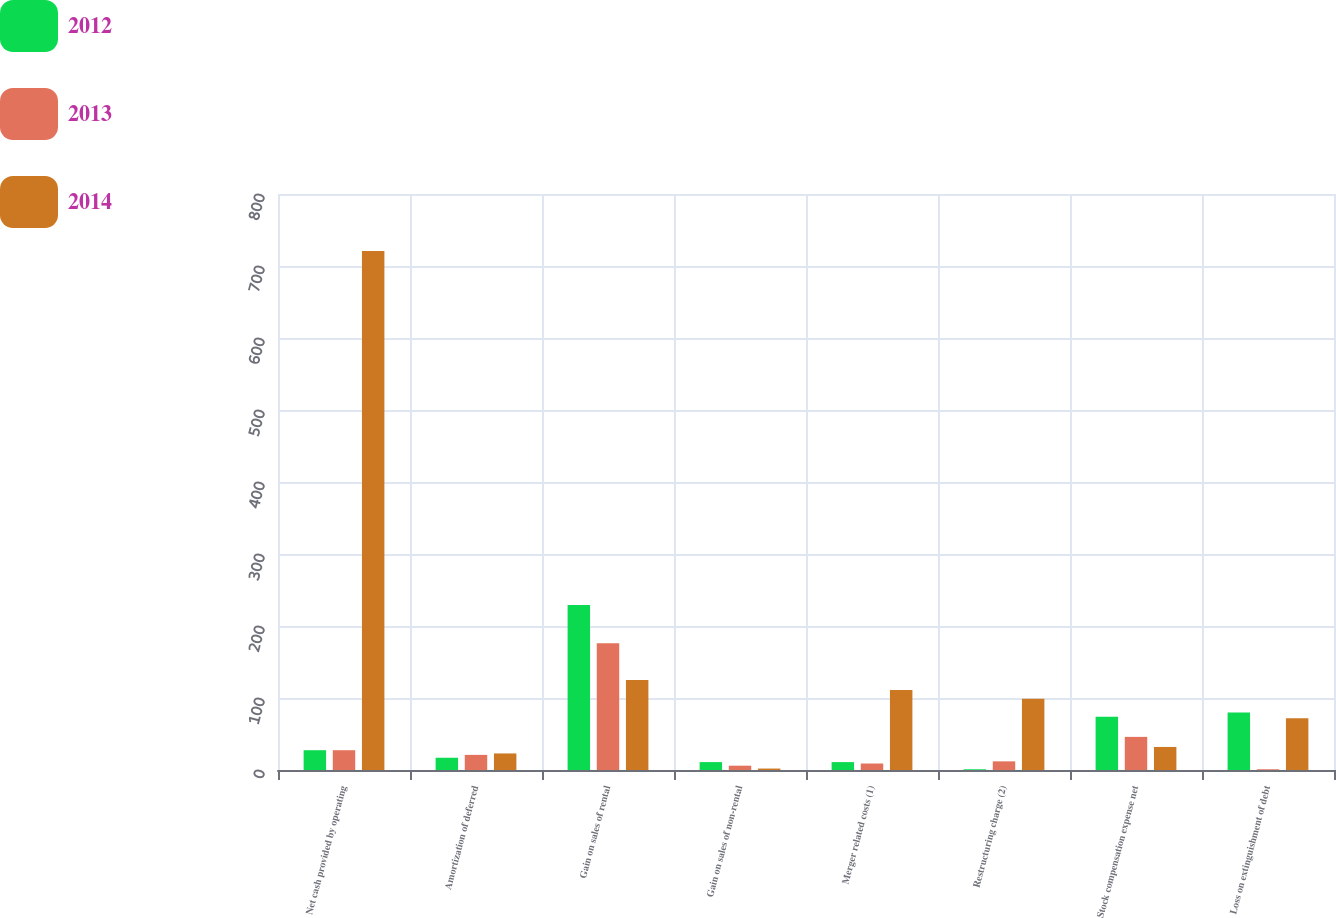Convert chart. <chart><loc_0><loc_0><loc_500><loc_500><stacked_bar_chart><ecel><fcel>Net cash provided by operating<fcel>Amortization of deferred<fcel>Gain on sales of rental<fcel>Gain on sales of non-rental<fcel>Merger related costs (1)<fcel>Restructuring charge (2)<fcel>Stock compensation expense net<fcel>Loss on extinguishment of debt<nl><fcel>2012<fcel>27.5<fcel>17<fcel>229<fcel>11<fcel>11<fcel>1<fcel>74<fcel>80<nl><fcel>2013<fcel>27.5<fcel>21<fcel>176<fcel>6<fcel>9<fcel>12<fcel>46<fcel>1<nl><fcel>2014<fcel>721<fcel>23<fcel>125<fcel>2<fcel>111<fcel>99<fcel>32<fcel>72<nl></chart> 